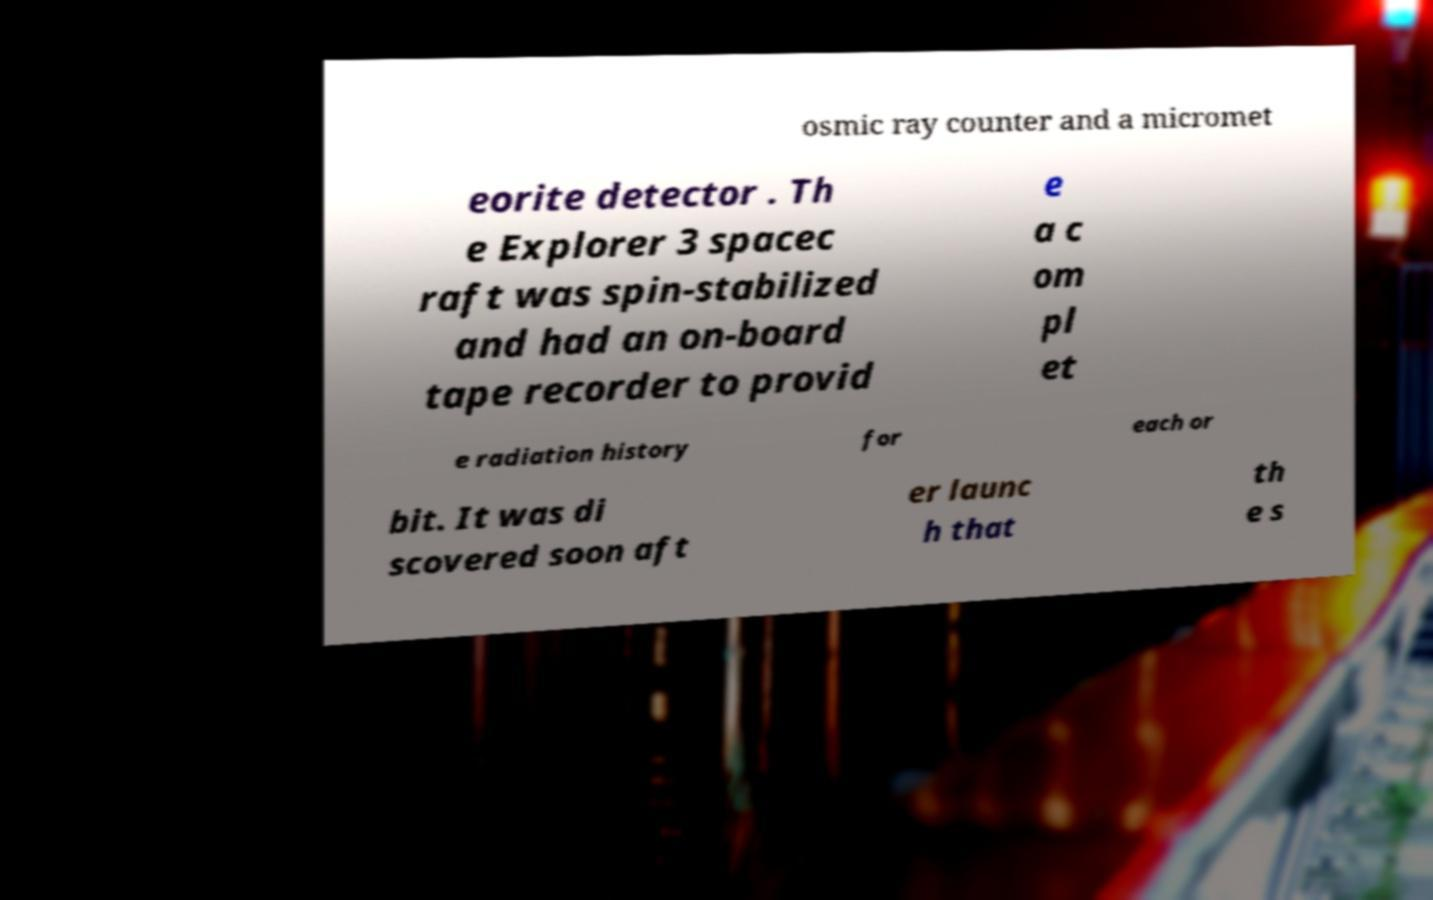What messages or text are displayed in this image? I need them in a readable, typed format. osmic ray counter and a micromet eorite detector . Th e Explorer 3 spacec raft was spin-stabilized and had an on-board tape recorder to provid e a c om pl et e radiation history for each or bit. It was di scovered soon aft er launc h that th e s 